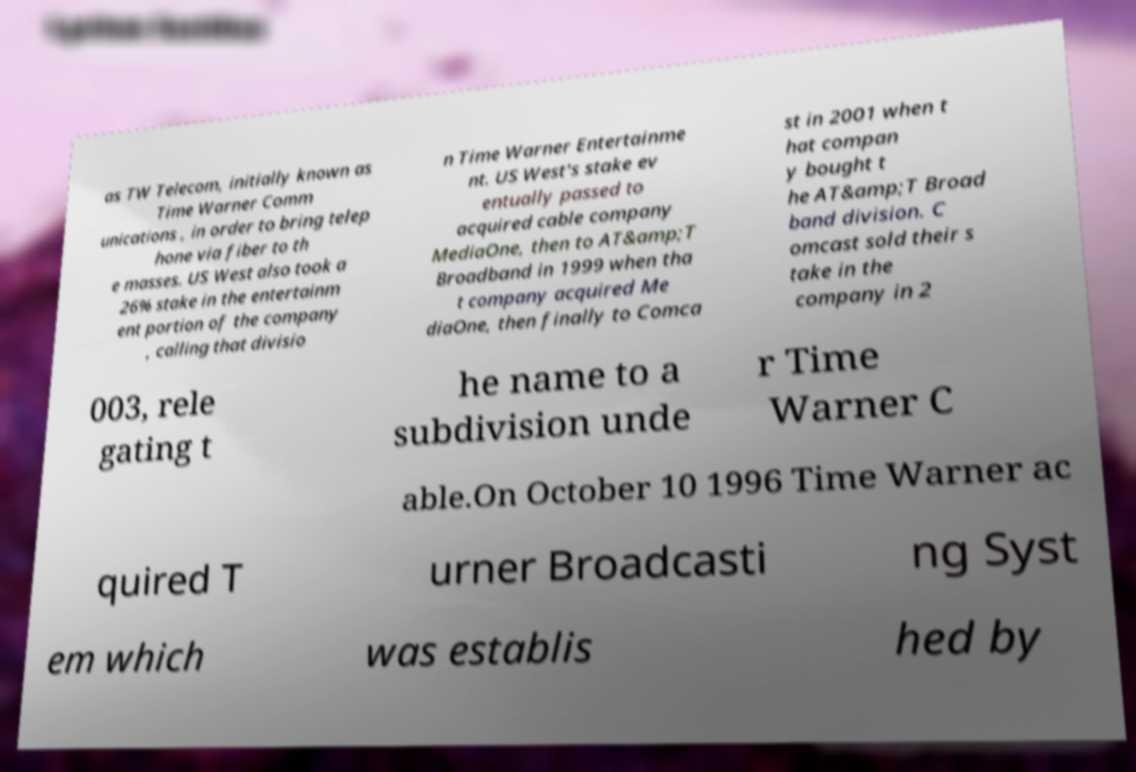There's text embedded in this image that I need extracted. Can you transcribe it verbatim? as TW Telecom, initially known as Time Warner Comm unications , in order to bring telep hone via fiber to th e masses. US West also took a 26% stake in the entertainm ent portion of the company , calling that divisio n Time Warner Entertainme nt. US West's stake ev entually passed to acquired cable company MediaOne, then to AT&amp;T Broadband in 1999 when tha t company acquired Me diaOne, then finally to Comca st in 2001 when t hat compan y bought t he AT&amp;T Broad band division. C omcast sold their s take in the company in 2 003, rele gating t he name to a subdivision unde r Time Warner C able.On October 10 1996 Time Warner ac quired T urner Broadcasti ng Syst em which was establis hed by 